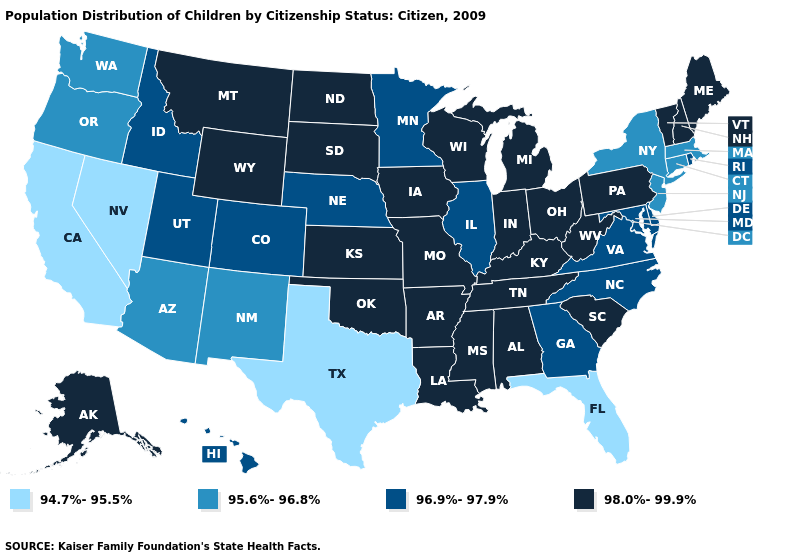Name the states that have a value in the range 98.0%-99.9%?
Concise answer only. Alabama, Alaska, Arkansas, Indiana, Iowa, Kansas, Kentucky, Louisiana, Maine, Michigan, Mississippi, Missouri, Montana, New Hampshire, North Dakota, Ohio, Oklahoma, Pennsylvania, South Carolina, South Dakota, Tennessee, Vermont, West Virginia, Wisconsin, Wyoming. What is the highest value in states that border New York?
Concise answer only. 98.0%-99.9%. Does the map have missing data?
Give a very brief answer. No. Which states have the lowest value in the USA?
Short answer required. California, Florida, Nevada, Texas. Name the states that have a value in the range 98.0%-99.9%?
Be succinct. Alabama, Alaska, Arkansas, Indiana, Iowa, Kansas, Kentucky, Louisiana, Maine, Michigan, Mississippi, Missouri, Montana, New Hampshire, North Dakota, Ohio, Oklahoma, Pennsylvania, South Carolina, South Dakota, Tennessee, Vermont, West Virginia, Wisconsin, Wyoming. Which states hav the highest value in the Northeast?
Keep it brief. Maine, New Hampshire, Pennsylvania, Vermont. What is the lowest value in the USA?
Short answer required. 94.7%-95.5%. Does the first symbol in the legend represent the smallest category?
Give a very brief answer. Yes. What is the lowest value in the USA?
Be succinct. 94.7%-95.5%. What is the value of Connecticut?
Short answer required. 95.6%-96.8%. Name the states that have a value in the range 94.7%-95.5%?
Quick response, please. California, Florida, Nevada, Texas. Among the states that border Louisiana , which have the highest value?
Be succinct. Arkansas, Mississippi. What is the value of Arkansas?
Give a very brief answer. 98.0%-99.9%. Does the first symbol in the legend represent the smallest category?
Be succinct. Yes. Name the states that have a value in the range 96.9%-97.9%?
Answer briefly. Colorado, Delaware, Georgia, Hawaii, Idaho, Illinois, Maryland, Minnesota, Nebraska, North Carolina, Rhode Island, Utah, Virginia. 